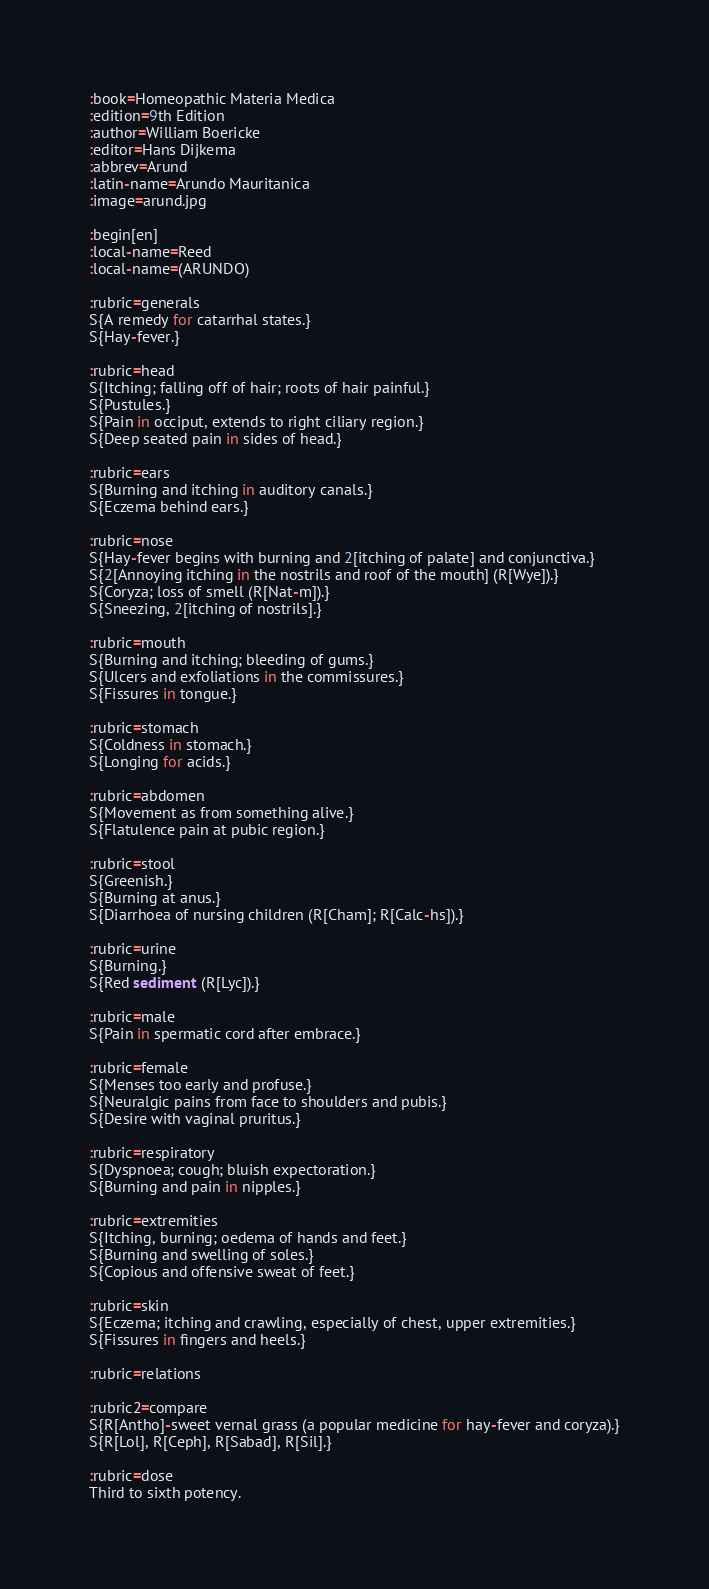Convert code to text. <code><loc_0><loc_0><loc_500><loc_500><_ObjectiveC_>:book=Homeopathic Materia Medica
:edition=9th Edition
:author=William Boericke
:editor=Hans Dijkema
:abbrev=Arund
:latin-name=Arundo Mauritanica
:image=arund.jpg

:begin[en]
:local-name=Reed
:local-name=(ARUNDO)

:rubric=generals
S{A remedy for catarrhal states.}
S{Hay-fever.}

:rubric=head
S{Itching; falling off of hair; roots of hair painful.}
S{Pustules.}
S{Pain in occiput, extends to right ciliary region.}
S{Deep seated pain in sides of head.}

:rubric=ears
S{Burning and itching in auditory canals.}
S{Eczema behind ears.}

:rubric=nose
S{Hay-fever begins with burning and 2[itching of palate] and conjunctiva.}
S{2[Annoying itching in the nostrils and roof of the mouth] (R[Wye]).}
S{Coryza; loss of smell (R[Nat-m]).}
S{Sneezing, 2[itching of nostrils].}

:rubric=mouth
S{Burning and itching; bleeding of gums.}
S{Ulcers and exfoliations in the commissures.}
S{Fissures in tongue.}

:rubric=stomach
S{Coldness in stomach.}
S{Longing for acids.}

:rubric=abdomen
S{Movement as from something alive.}
S{Flatulence pain at pubic region.}

:rubric=stool
S{Greenish.}
S{Burning at anus.}
S{Diarrhoea of nursing children (R[Cham]; R[Calc-hs]).}

:rubric=urine
S{Burning.}
S{Red sediment (R[Lyc]).}

:rubric=male
S{Pain in spermatic cord after embrace.}

:rubric=female
S{Menses too early and profuse.}
S{Neuralgic pains from face to shoulders and pubis.}
S{Desire with vaginal pruritus.}

:rubric=respiratory
S{Dyspnoea; cough; bluish expectoration.}
S{Burning and pain in nipples.}

:rubric=extremities
S{Itching, burning; oedema of hands and feet.}
S{Burning and swelling of soles.}
S{Copious and offensive sweat of feet.}

:rubric=skin
S{Eczema; itching and crawling, especially of chest, upper extremities.}
S{Fissures in fingers and heels.}

:rubric=relations

:rubric2=compare
S{R[Antho]-sweet vernal grass (a popular medicine for hay-fever and coryza).}
S{R[Lol], R[Ceph], R[Sabad], R[Sil].}

:rubric=dose
Third to sixth potency.</code> 